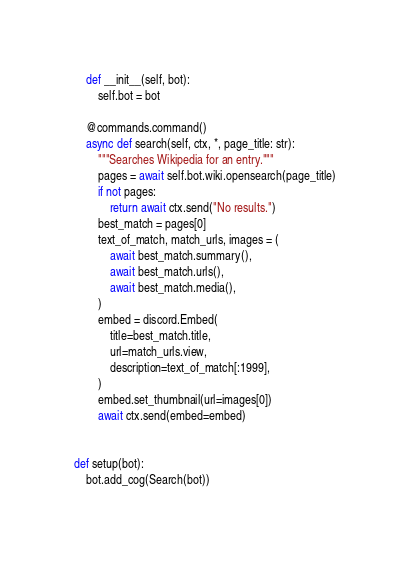<code> <loc_0><loc_0><loc_500><loc_500><_Python_>    def __init__(self, bot):
        self.bot = bot

    @commands.command()
    async def search(self, ctx, *, page_title: str):
        """Searches Wikipedia for an entry."""
        pages = await self.bot.wiki.opensearch(page_title)
        if not pages:
            return await ctx.send("No results.")
        best_match = pages[0]
        text_of_match, match_urls, images = (
            await best_match.summary(),
            await best_match.urls(),
            await best_match.media(),
        )
        embed = discord.Embed(
            title=best_match.title,
            url=match_urls.view,
            description=text_of_match[:1999],
        )
        embed.set_thumbnail(url=images[0])
        await ctx.send(embed=embed)


def setup(bot):
    bot.add_cog(Search(bot))
</code> 